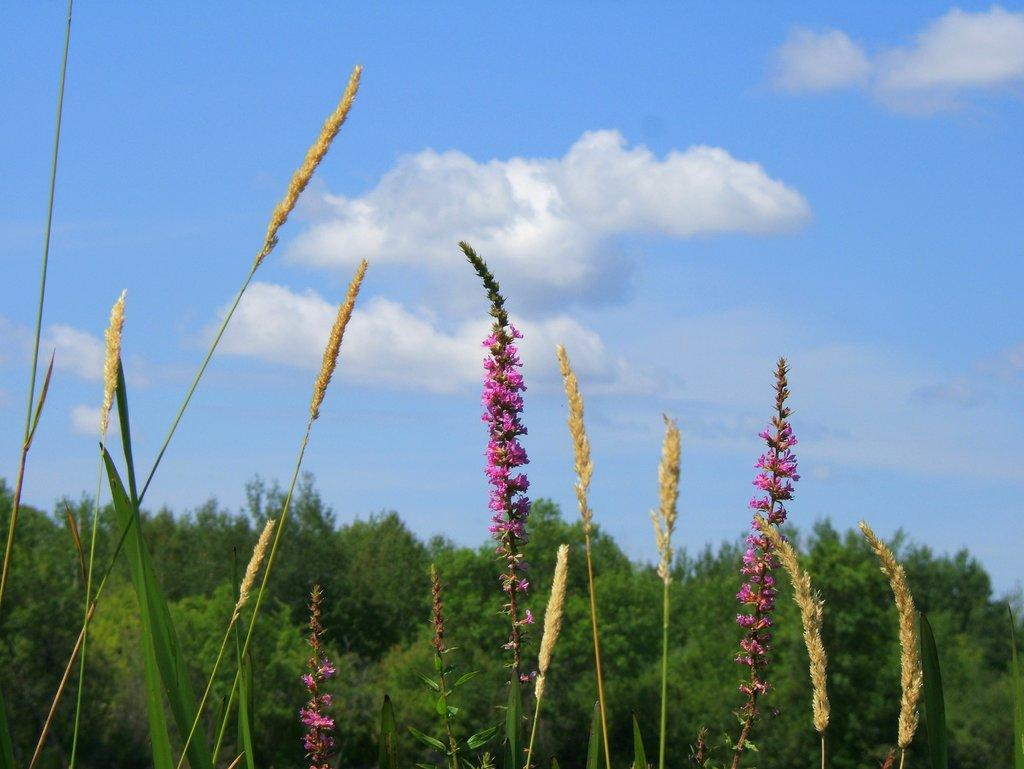What type of plants can be seen in the image? There are flowers in the image. What part of the flowers is visible in the image? The flowers have stems in the image. What can be seen in the background of the image? Trees and the sky are visible in the background of the image. What year was the decision made to plant the flowers in the image? There is no information about the year or decision-making process related to planting the flowers in the image. 